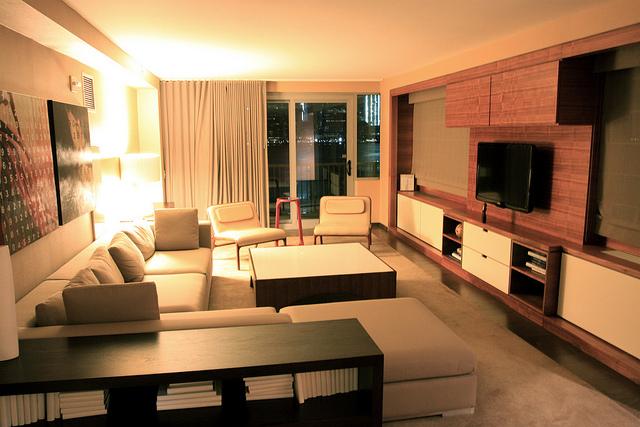Is the tv on?
Write a very short answer. No. What color is the furniture in this room?
Be succinct. White. Is the TV sitting on a stand?
Keep it brief. No. 